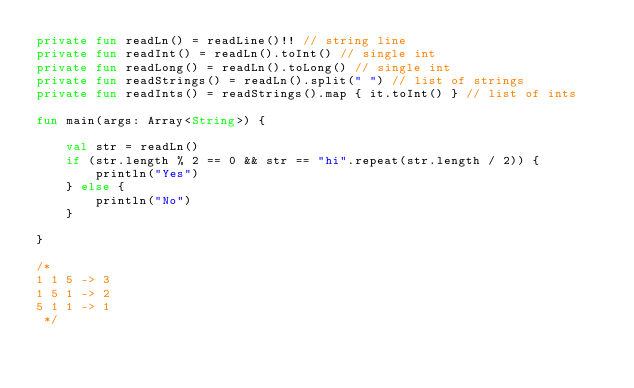Convert code to text. <code><loc_0><loc_0><loc_500><loc_500><_Kotlin_>private fun readLn() = readLine()!! // string line
private fun readInt() = readLn().toInt() // single int
private fun readLong() = readLn().toLong() // single int
private fun readStrings() = readLn().split(" ") // list of strings
private fun readInts() = readStrings().map { it.toInt() } // list of ints

fun main(args: Array<String>) {

    val str = readLn()
    if (str.length % 2 == 0 && str == "hi".repeat(str.length / 2)) {
        println("Yes")
    } else {
        println("No")
    }

}

/*
1 1 5 -> 3
1 5 1 -> 2
5 1 1 -> 1
 */
</code> 